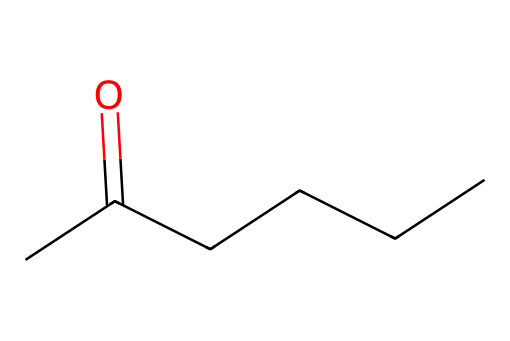What is the molecular formula of this aldehyde? To find the molecular formula, we count the number of carbon (C), hydrogen (H), and oxygen (O) atoms present in the SMILES representation. There are 6 carbon atoms, 12 hydrogen atoms, and 1 oxygen atom. Therefore, the molecular formula is C6H12O.
Answer: C6H12O How many hydrogen atoms are in this molecule? By examining the molecular structure, we observe that there are 12 hydrogen atoms present linked to the carbon backbone of the aldehyde.
Answer: 12 What type of carbon functional group is present here? The presence of the carbonyl group (=O) at the end of the carbon chain designates this molecule as having an aldehyde functional group.
Answer: aldehyde What is the total number of carbon atoms in this compound? Counting the number of carbon atoms in the structure from the SMILES shows a total of 6 carbon atoms linked linearly.
Answer: 6 What role do aldehydes often play in aviation lubricants? Aldehydes can function as additives in lubricants to improve stability, reduce friction, and enhance performance characteristics due to their chemical reactivity and lubricating properties.
Answer: additives Does this aldehyde have a straight-chain or branched structure? The structure's linear arrangement of carbon atoms indicates that this aldehyde is a straight-chain compound, as there are no branches in the carbon skeleton.
Answer: straight-chain 